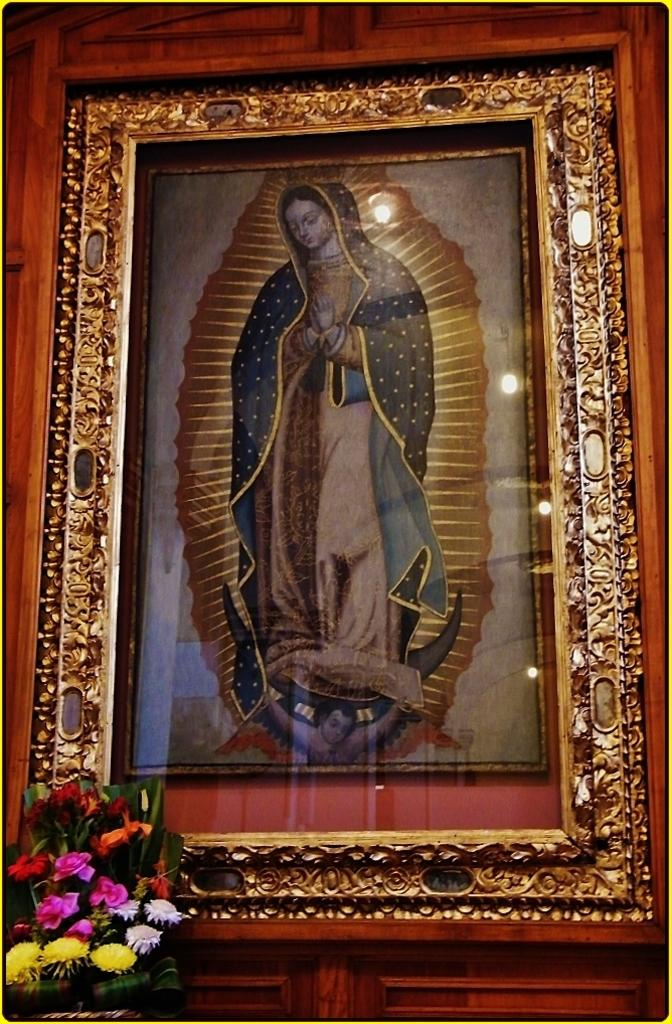What type of plant is visible in the image? There is a plant with flowers in the image. What can be seen in the background of the image? There is a photo frame with lights in the background of the image. What type of engine is visible in the image? There is no engine present in the image; it features a plant with flowers and a photo frame with lights. How many pickles are on the plant in the image? There are no pickles present on the plant in the image; it is a plant with flowers. 